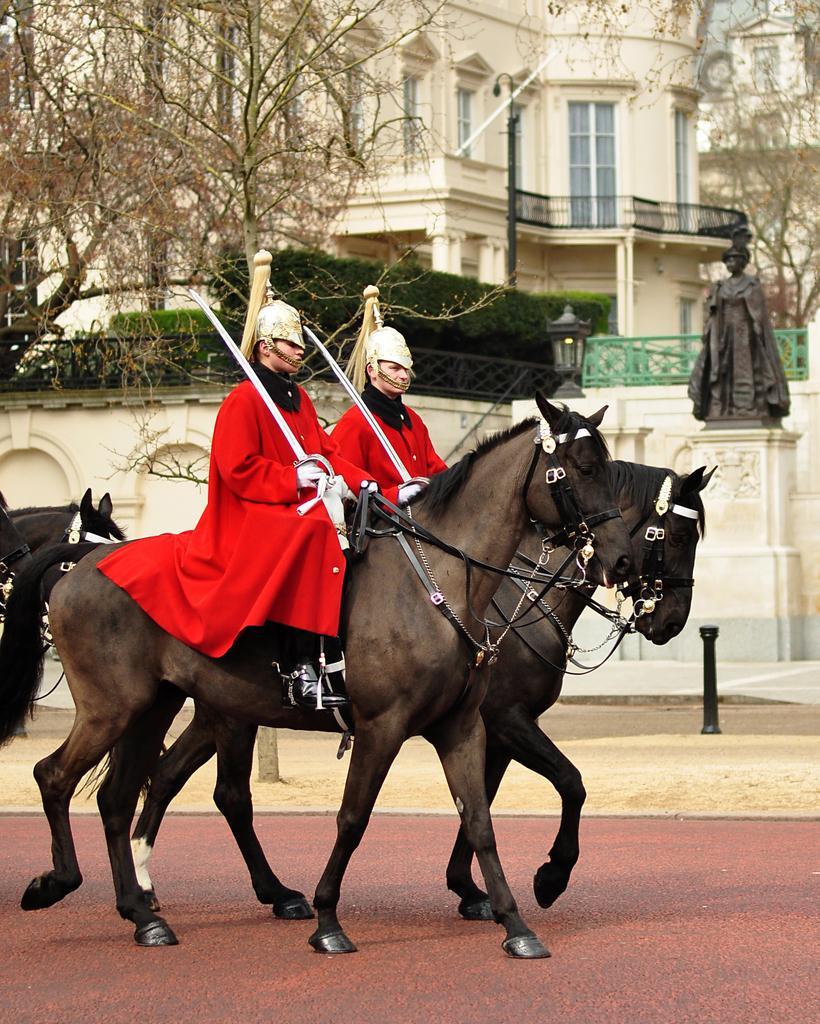Could you give a brief overview of what you see in this image? In the image there are two men holding swords in their hands and they are sitting on the horses. Behind them there are horses. Behind the horses there is a pole and also there is a statue on the pedestal. Behind the pedestal there is a wall with arches, designs and fencing. Behind the fencing there are bushes and also there are trees. Behind them there are buildings with walls, glass windows and railings. 